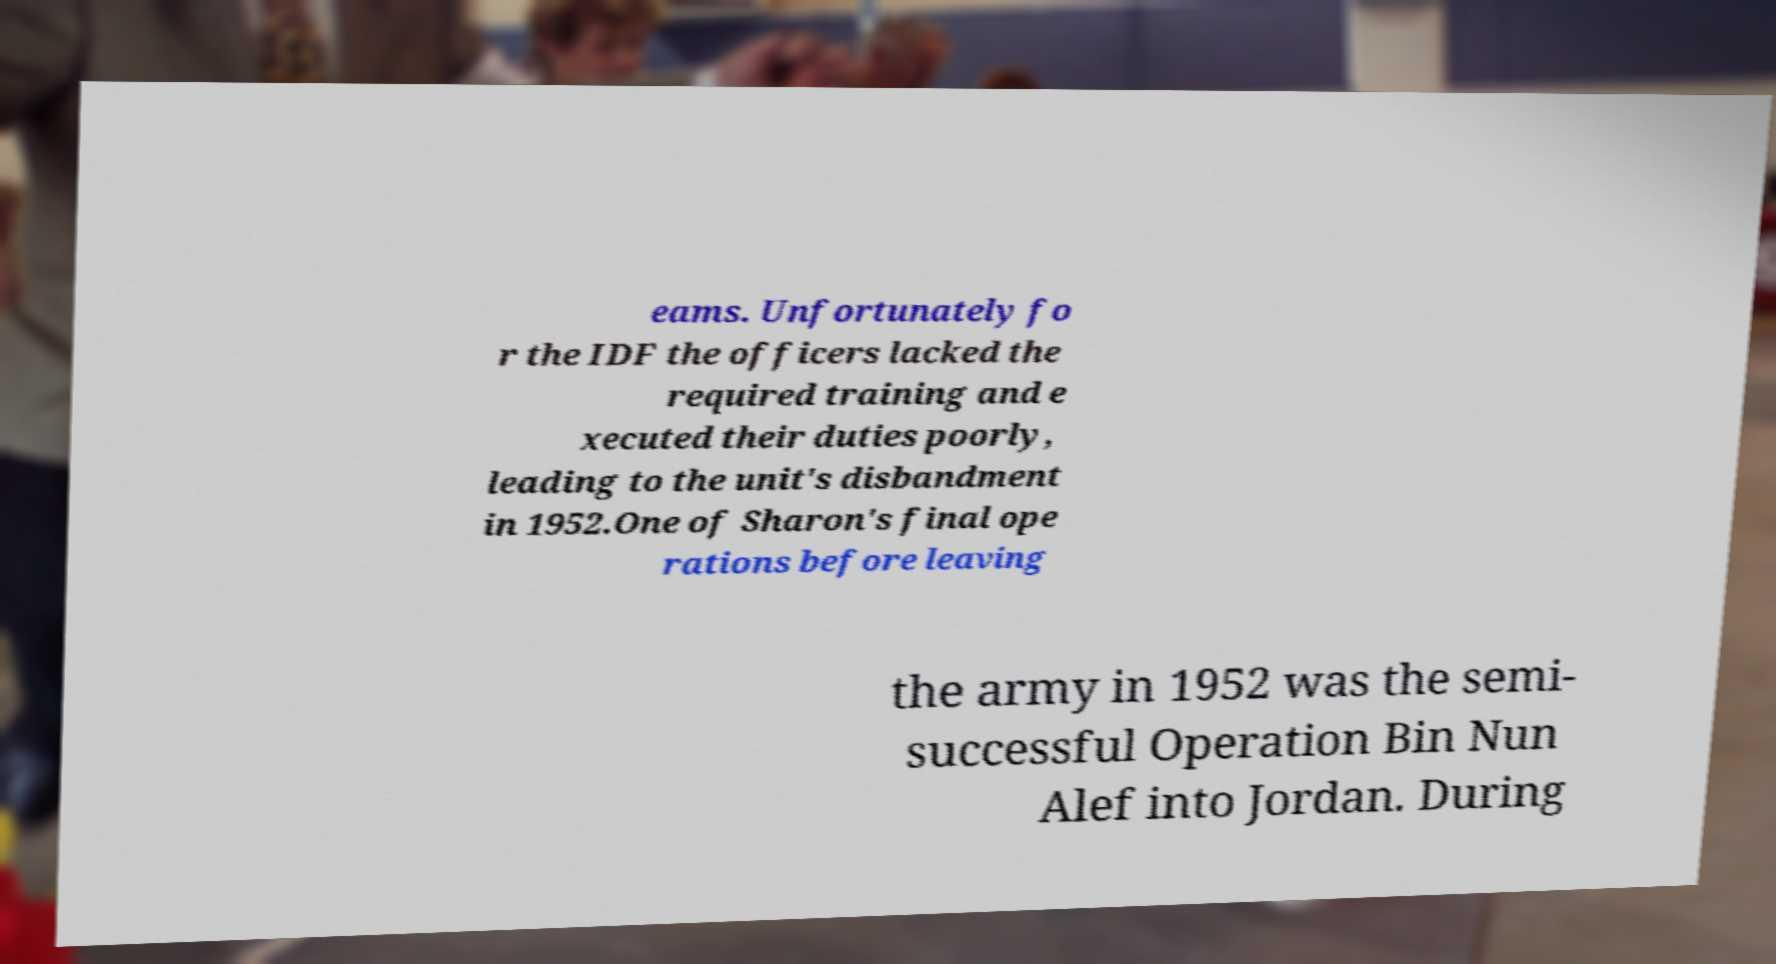What messages or text are displayed in this image? I need them in a readable, typed format. eams. Unfortunately fo r the IDF the officers lacked the required training and e xecuted their duties poorly, leading to the unit's disbandment in 1952.One of Sharon's final ope rations before leaving the army in 1952 was the semi- successful Operation Bin Nun Alef into Jordan. During 